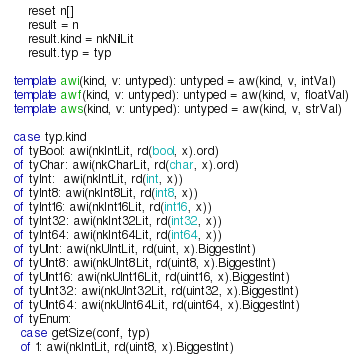<code> <loc_0><loc_0><loc_500><loc_500><_Nim_>      reset n[]
      result = n
      result.kind = nkNilLit
      result.typ = typ

  template awi(kind, v: untyped): untyped = aw(kind, v, intVal)
  template awf(kind, v: untyped): untyped = aw(kind, v, floatVal)
  template aws(kind, v: untyped): untyped = aw(kind, v, strVal)

  case typ.kind
  of tyBool: awi(nkIntLit, rd(bool, x).ord)
  of tyChar: awi(nkCharLit, rd(char, x).ord)
  of tyInt:  awi(nkIntLit, rd(int, x))
  of tyInt8: awi(nkInt8Lit, rd(int8, x))
  of tyInt16: awi(nkInt16Lit, rd(int16, x))
  of tyInt32: awi(nkInt32Lit, rd(int32, x))
  of tyInt64: awi(nkInt64Lit, rd(int64, x))
  of tyUInt: awi(nkUIntLit, rd(uint, x).BiggestInt)
  of tyUInt8: awi(nkUInt8Lit, rd(uint8, x).BiggestInt)
  of tyUInt16: awi(nkUInt16Lit, rd(uint16, x).BiggestInt)
  of tyUInt32: awi(nkUInt32Lit, rd(uint32, x).BiggestInt)
  of tyUInt64: awi(nkUInt64Lit, rd(uint64, x).BiggestInt)
  of tyEnum:
    case getSize(conf, typ)
    of 1: awi(nkIntLit, rd(uint8, x).BiggestInt)</code> 